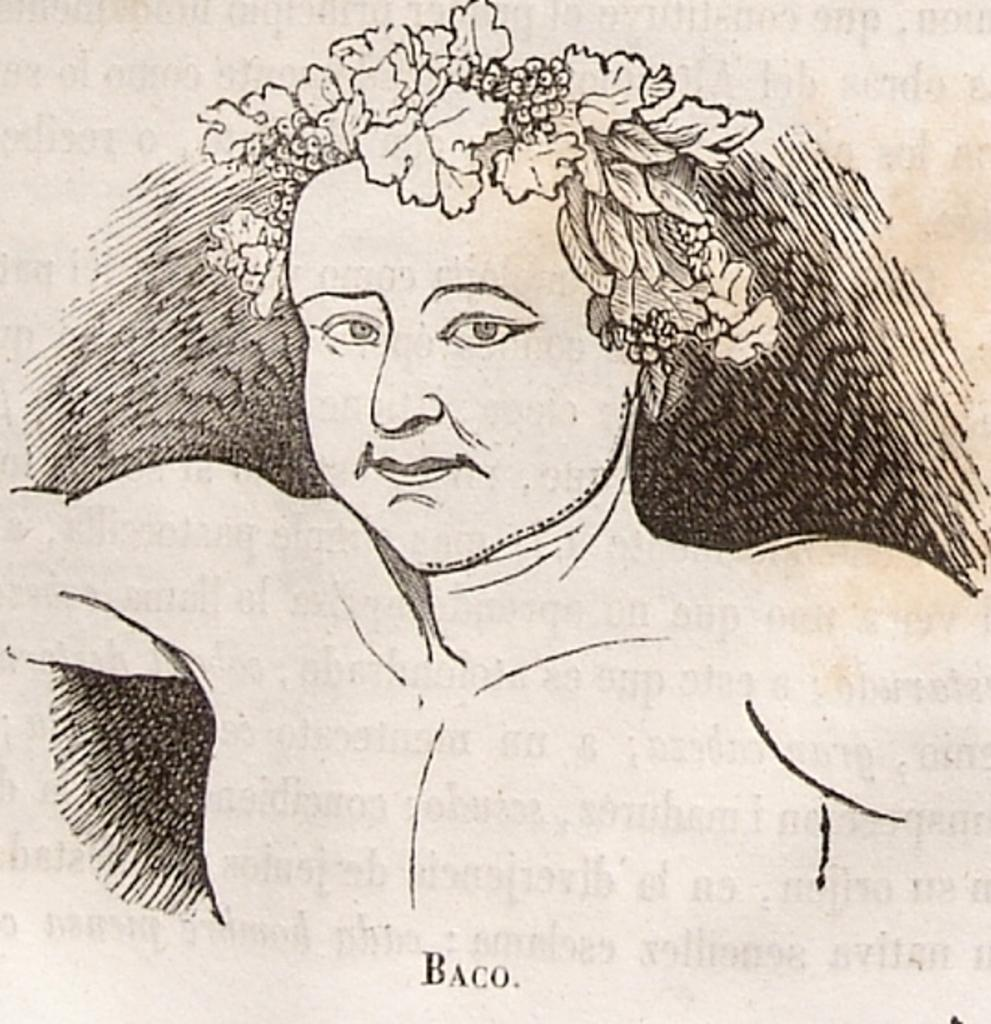What is depicted in the image? There is a drawing of a woman in the image. What is unique about the woman's appearance? The woman has a flower costume in her hair. What type of mountain can be seen in the background of the image? There is no mountain present in the image; it features a drawing of a woman with a flower costume in her hair. 